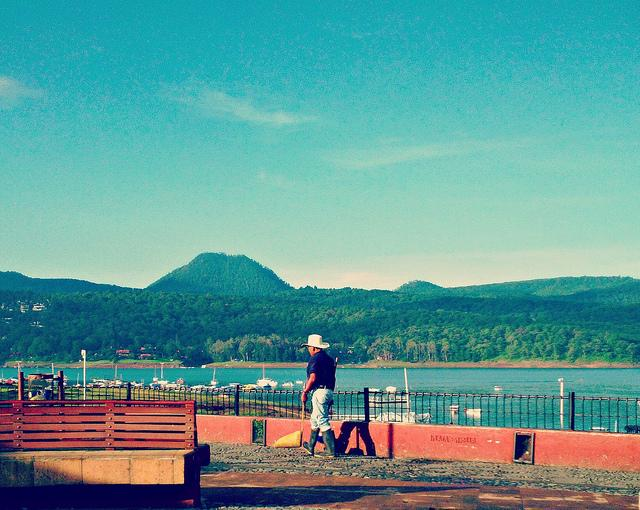What is the man wearing that is made of rubber?

Choices:
A) vest
B) shirt
C) pants
D) boots boots 